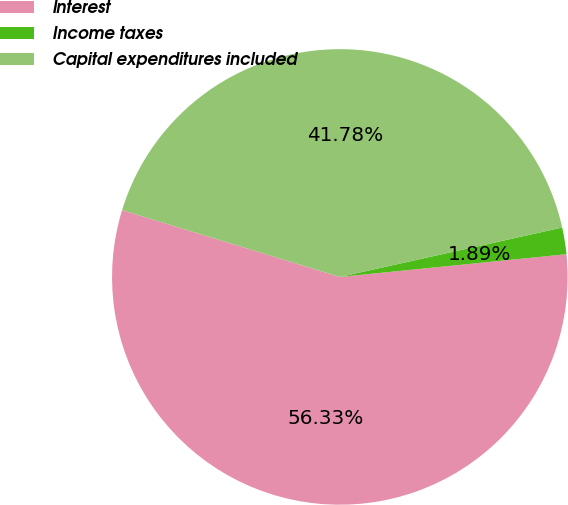<chart> <loc_0><loc_0><loc_500><loc_500><pie_chart><fcel>Interest<fcel>Income taxes<fcel>Capital expenditures included<nl><fcel>56.33%<fcel>1.89%<fcel>41.78%<nl></chart> 